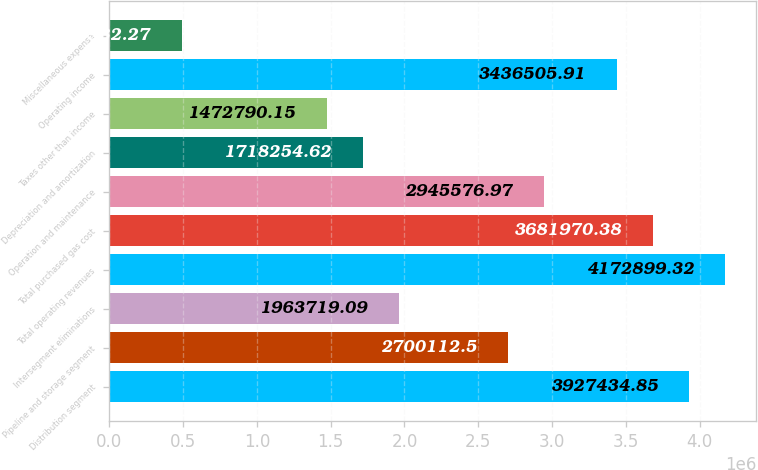Convert chart. <chart><loc_0><loc_0><loc_500><loc_500><bar_chart><fcel>Distribution segment<fcel>Pipeline and storage segment<fcel>Intersegment eliminations<fcel>Total operating revenues<fcel>Total purchased gas cost<fcel>Operation and maintenance<fcel>Depreciation and amortization<fcel>Taxes other than income<fcel>Operating income<fcel>Miscellaneous expense<nl><fcel>3.92743e+06<fcel>2.70011e+06<fcel>1.96372e+06<fcel>4.1729e+06<fcel>3.68197e+06<fcel>2.94558e+06<fcel>1.71825e+06<fcel>1.47279e+06<fcel>3.43651e+06<fcel>490932<nl></chart> 